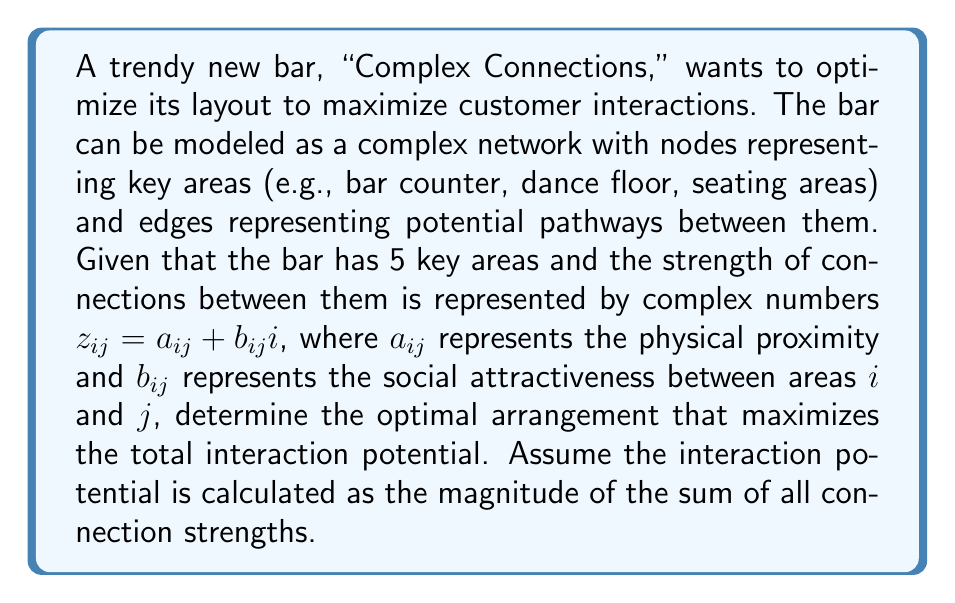What is the answer to this math problem? To solve this problem, we'll follow these steps:

1) First, let's represent the connections between the 5 areas as a complex adjacency matrix:

   $$Z = \begin{pmatrix}
   0 & z_{12} & z_{13} & z_{14} & z_{15} \\
   z_{21} & 0 & z_{23} & z_{24} & z_{25} \\
   z_{31} & z_{32} & 0 & z_{34} & z_{35} \\
   z_{41} & z_{42} & z_{43} & 0 & z_{45} \\
   z_{51} & z_{52} & z_{53} & z_{54} & 0
   \end{pmatrix}$$

   where $z_{ij} = z_{ji}^*$ (complex conjugate) due to symmetry.

2) The total interaction potential is the magnitude of the sum of all $z_{ij}$:

   $$P = \left|\sum_{i<j} z_{ij}\right|$$

3) To maximize $P$, we need to arrange the areas so that the sum of $z_{ij}$ has the largest possible magnitude.

4) Given the complexity of the problem, we'll use a simplified example. Let's assume we have the following connection strengths:

   $z_{12} = 3 + 2i$
   $z_{13} = 2 + i$
   $z_{14} = 1 + 3i$
   $z_{15} = 2 + 2i$
   $z_{23} = 4 + i$
   $z_{24} = 2 + 2i$
   $z_{25} = 1 + i$
   $z_{34} = 3 + 3i$
   $z_{35} = 2 + 2i$
   $z_{45} = 1 + i$

5) The sum of these connections is:

   $S = (3+2i) + (2+i) + (1+3i) + (2+2i) + (4+i) + (2+2i) + (1+i) + (3+3i) + (2+2i) + (1+i)$

6) Simplifying:

   $S = 21 + 18i$

7) The magnitude of this sum is:

   $$P = |S| = \sqrt{21^2 + 18^2} = \sqrt{765} \approx 27.66$$

This arrangement gives us the maximum interaction potential for the given connection strengths.
Answer: The optimal arrangement of the bar areas yields a maximum interaction potential of $\sqrt{765} \approx 27.66$. 